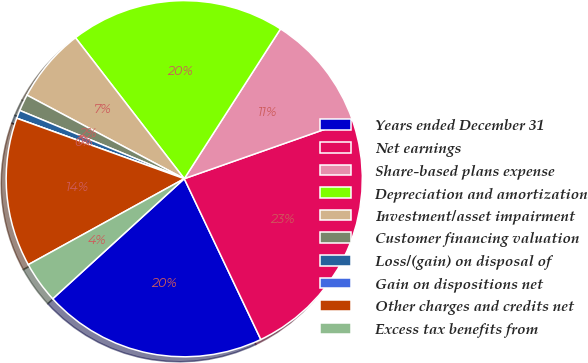Convert chart to OTSL. <chart><loc_0><loc_0><loc_500><loc_500><pie_chart><fcel>Years ended December 31<fcel>Net earnings<fcel>Share-based plans expense<fcel>Depreciation and amortization<fcel>Investment/asset impairment<fcel>Customer financing valuation<fcel>Loss/(gain) on disposal of<fcel>Gain on dispositions net<fcel>Other charges and credits net<fcel>Excess tax benefits from<nl><fcel>20.3%<fcel>23.31%<fcel>10.53%<fcel>19.55%<fcel>6.77%<fcel>1.51%<fcel>0.75%<fcel>0.0%<fcel>13.53%<fcel>3.76%<nl></chart> 